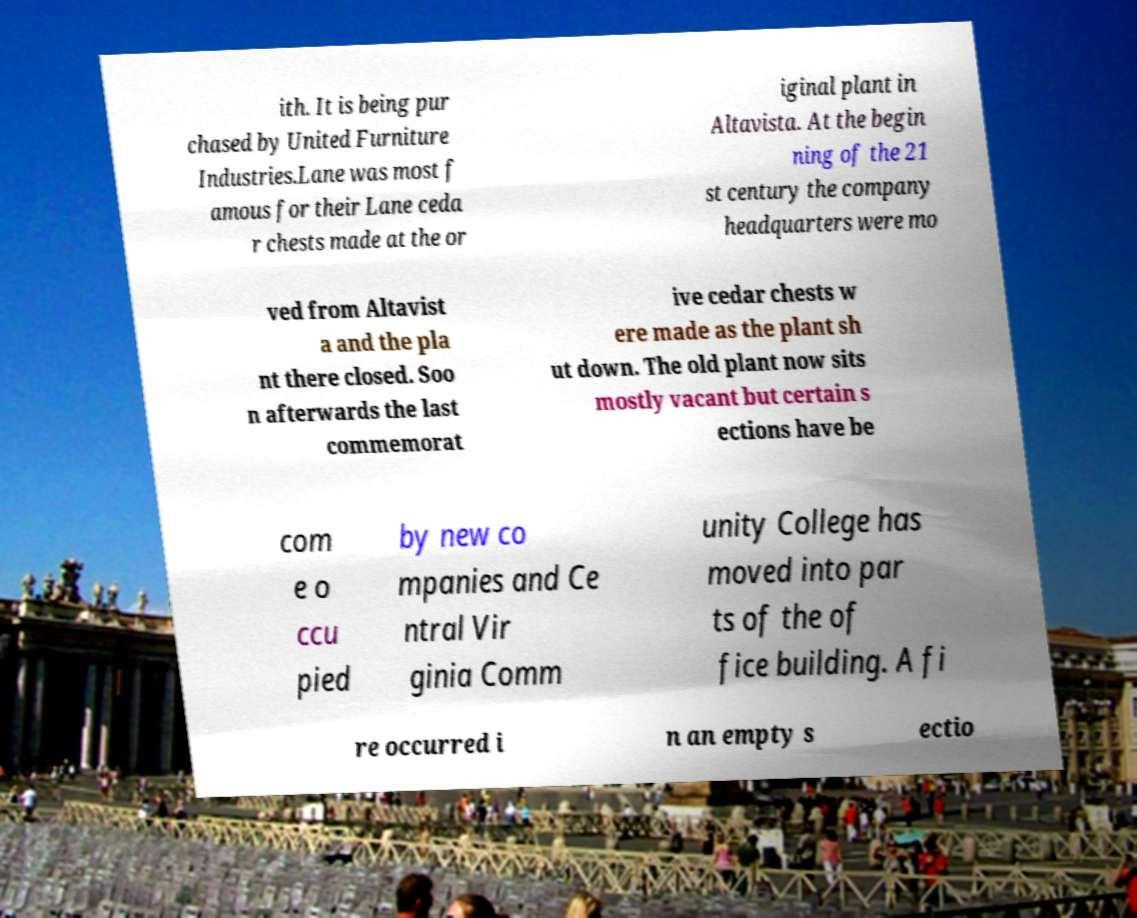Can you accurately transcribe the text from the provided image for me? ith. It is being pur chased by United Furniture Industries.Lane was most f amous for their Lane ceda r chests made at the or iginal plant in Altavista. At the begin ning of the 21 st century the company headquarters were mo ved from Altavist a and the pla nt there closed. Soo n afterwards the last commemorat ive cedar chests w ere made as the plant sh ut down. The old plant now sits mostly vacant but certain s ections have be com e o ccu pied by new co mpanies and Ce ntral Vir ginia Comm unity College has moved into par ts of the of fice building. A fi re occurred i n an empty s ectio 